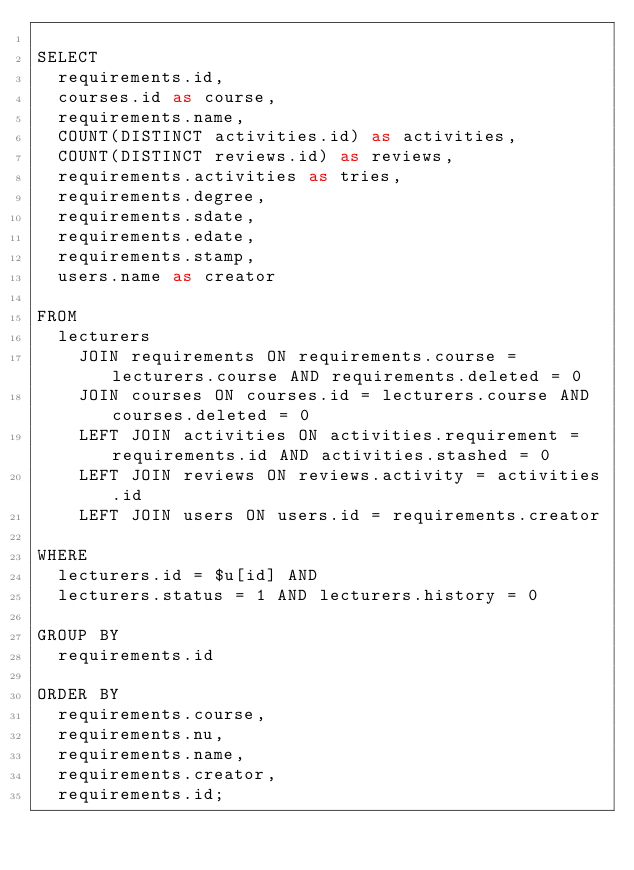Convert code to text. <code><loc_0><loc_0><loc_500><loc_500><_SQL_>
SELECT
  requirements.id,
  courses.id as course,
  requirements.name,
  COUNT(DISTINCT activities.id) as activities,
  COUNT(DISTINCT reviews.id) as reviews,
  requirements.activities as tries,
  requirements.degree,
  requirements.sdate,
  requirements.edate,
  requirements.stamp,
  users.name as creator

FROM
  lecturers
    JOIN requirements ON requirements.course = lecturers.course AND requirements.deleted = 0
    JOIN courses ON courses.id = lecturers.course AND courses.deleted = 0
    LEFT JOIN activities ON activities.requirement = requirements.id AND activities.stashed = 0
    LEFT JOIN reviews ON reviews.activity = activities.id
    LEFT JOIN users ON users.id = requirements.creator

WHERE
  lecturers.id = $u[id] AND
  lecturers.status = 1 AND lecturers.history = 0

GROUP BY
  requirements.id
  
ORDER BY
  requirements.course,
  requirements.nu,
  requirements.name,
  requirements.creator,
  requirements.id;</code> 